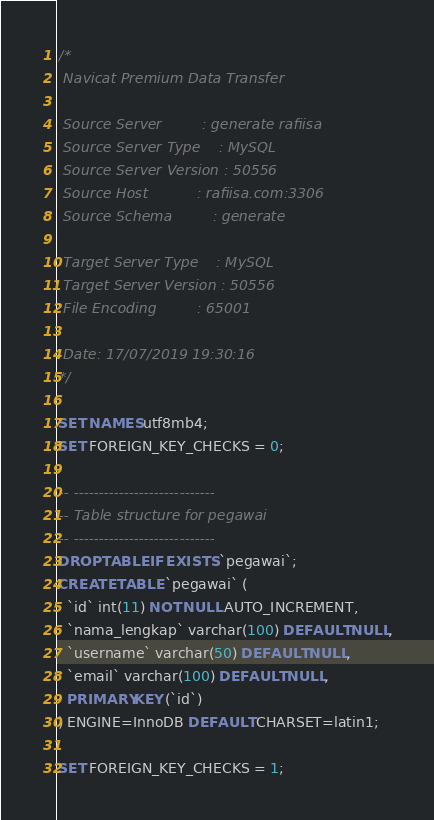Convert code to text. <code><loc_0><loc_0><loc_500><loc_500><_SQL_>/*
 Navicat Premium Data Transfer

 Source Server         : generate rafiisa
 Source Server Type    : MySQL
 Source Server Version : 50556
 Source Host           : rafiisa.com:3306
 Source Schema         : generate

 Target Server Type    : MySQL
 Target Server Version : 50556
 File Encoding         : 65001

 Date: 17/07/2019 19:30:16
*/

SET NAMES utf8mb4;
SET FOREIGN_KEY_CHECKS = 0;

-- ----------------------------
-- Table structure for pegawai
-- ----------------------------
DROP TABLE IF EXISTS `pegawai`;
CREATE TABLE `pegawai` (
  `id` int(11) NOT NULL AUTO_INCREMENT,
  `nama_lengkap` varchar(100) DEFAULT NULL,
  `username` varchar(50) DEFAULT NULL,
  `email` varchar(100) DEFAULT NULL,
  PRIMARY KEY (`id`)
) ENGINE=InnoDB DEFAULT CHARSET=latin1;

SET FOREIGN_KEY_CHECKS = 1;
</code> 